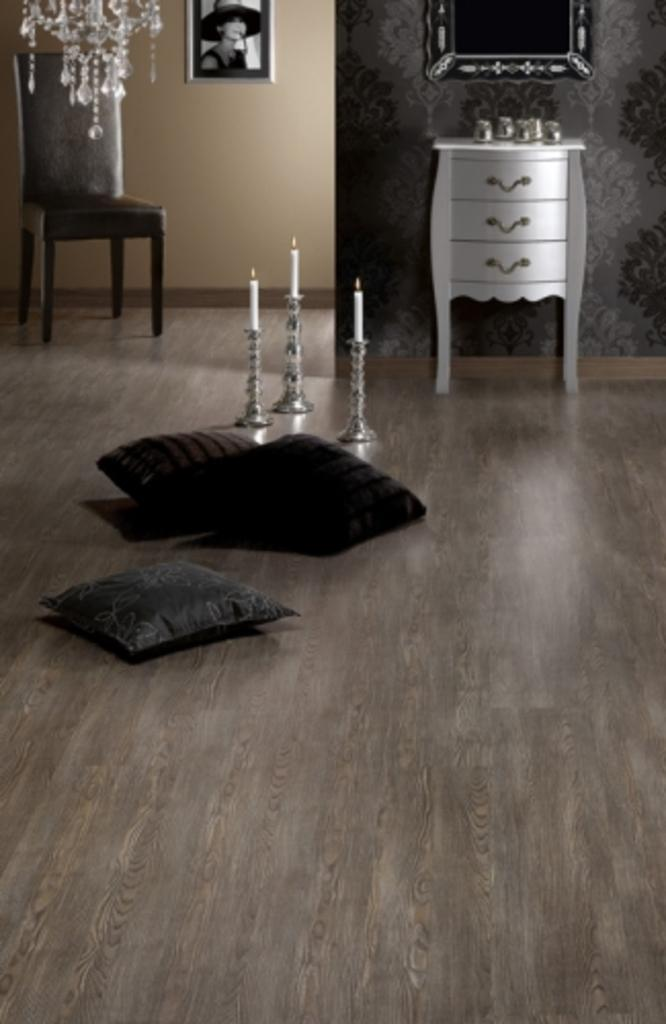What type of structure can be seen in the image? There is a wall in the image. What is hanging on the wall? There is a photo frame in the image. What type of furniture is present in the image? There is a chair in the image. What type of lighting is present in the image? There are candles in the image. What type of reflective surface is present in the image? There is a mirror in the image. What type of soft furnishings are present in the image? There are pillows in the image. What type of wood is used to make the spoon in the image? There is no spoon present in the image. What type of pail is visible in the image? There is no pail present in the image. 